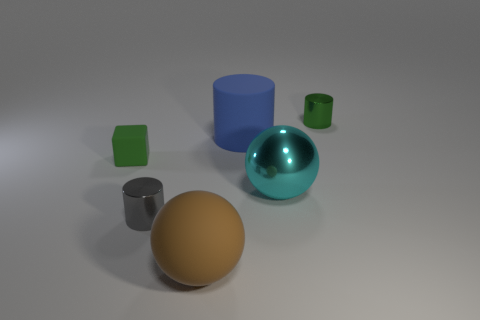Add 3 brown spheres. How many objects exist? 9 Subtract all spheres. How many objects are left? 4 Subtract 0 yellow spheres. How many objects are left? 6 Subtract all big yellow rubber cylinders. Subtract all big cyan spheres. How many objects are left? 5 Add 4 big brown spheres. How many big brown spheres are left? 5 Add 2 large green blocks. How many large green blocks exist? 2 